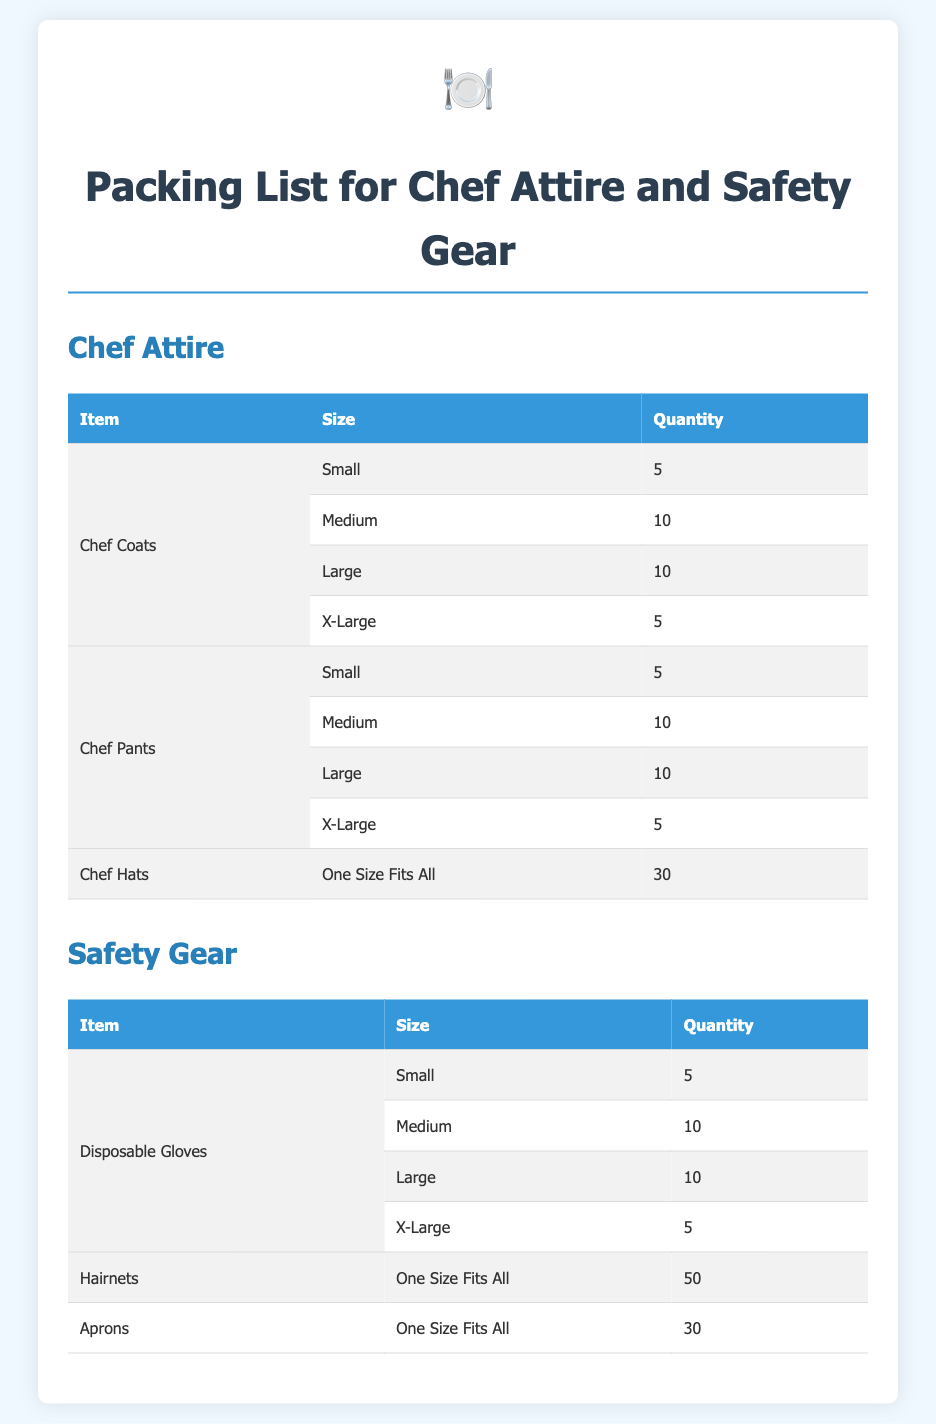What is the total number of chef coats? The total number of chef coats is the sum of all sizes listed: 5 + 10 + 10 + 5 = 30.
Answer: 30 How many chef hats are included in the packing list? The packing list specifically mentions that there are 30 chef hats, as indicated in the table.
Answer: 30 What is the quantity of large disposable gloves? The quantity of large disposable gloves is listed as 10 in the safety gear section of the packing list.
Answer: 10 How many different sizes are listed for chef pants? There are 4 different sizes listed for chef pants: Small, Medium, Large, and X-Large.
Answer: 4 Which safety gear item has the highest quantity? The item with the highest quantity in the safety gear section is hairnets, which are listed as 50.
Answer: Hairnets What size do the aprons come in? The aprons are listed as "One Size Fits All" in the safety gear section.
Answer: One Size Fits All What is the total quantity of large chef pants? The total quantity of large chef pants is 10, as stated in the chef attire section.
Answer: 10 How many disposable gloves are there in the small size? There are 5 disposable gloves in the small size, according to the packing list.
Answer: 5 What is the total number of chef attire items listed? The total number of chef attire items is the sum from all categories: (30 chef coats + 30 chef pants + 30 chef hats) = 90.
Answer: 90 